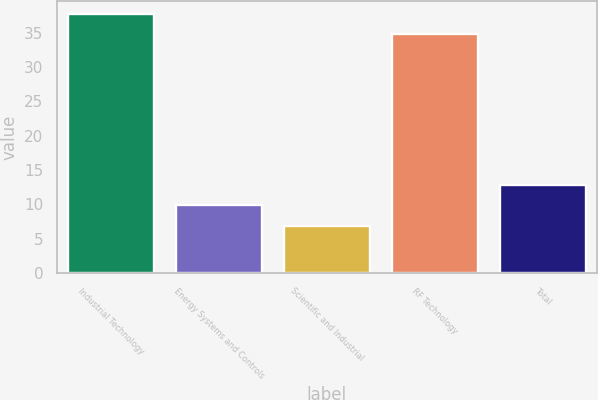<chart> <loc_0><loc_0><loc_500><loc_500><bar_chart><fcel>Industrial Technology<fcel>Energy Systems and Controls<fcel>Scientific and Industrial<fcel>RF Technology<fcel>Total<nl><fcel>37.76<fcel>9.86<fcel>6.9<fcel>34.8<fcel>12.82<nl></chart> 